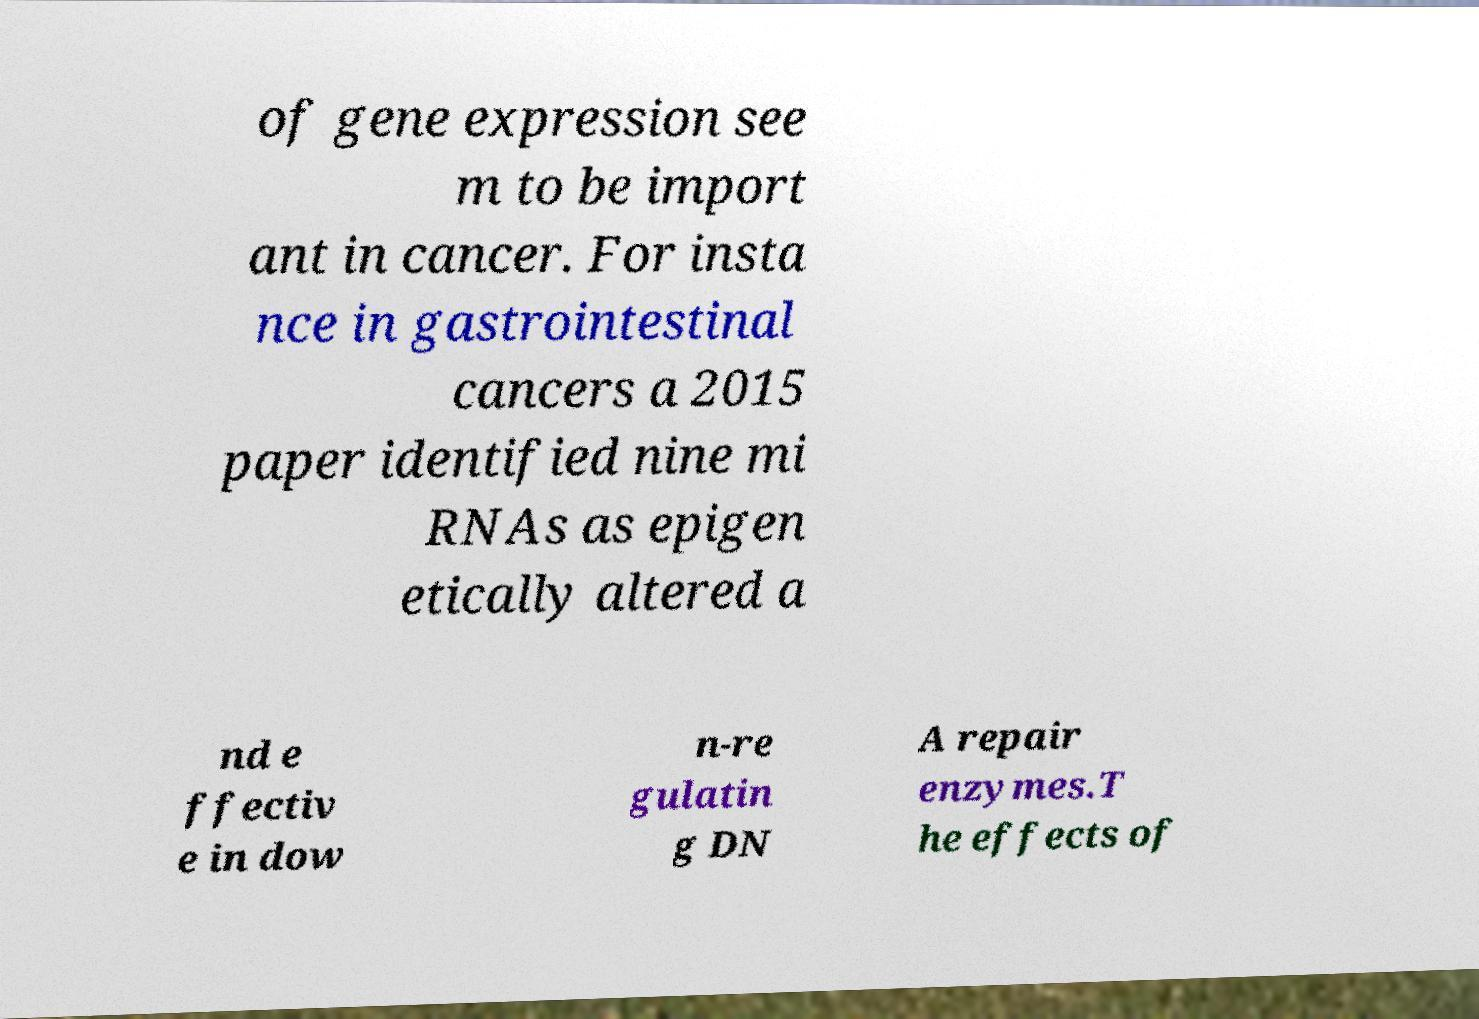Can you read and provide the text displayed in the image?This photo seems to have some interesting text. Can you extract and type it out for me? of gene expression see m to be import ant in cancer. For insta nce in gastrointestinal cancers a 2015 paper identified nine mi RNAs as epigen etically altered a nd e ffectiv e in dow n-re gulatin g DN A repair enzymes.T he effects of 